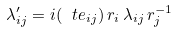Convert formula to latex. <formula><loc_0><loc_0><loc_500><loc_500>\lambda ^ { \prime } _ { i j } = i ( \ t e _ { i j } ) \, r _ { i } \, \lambda _ { i j } \, r _ { j } ^ { - 1 }</formula> 